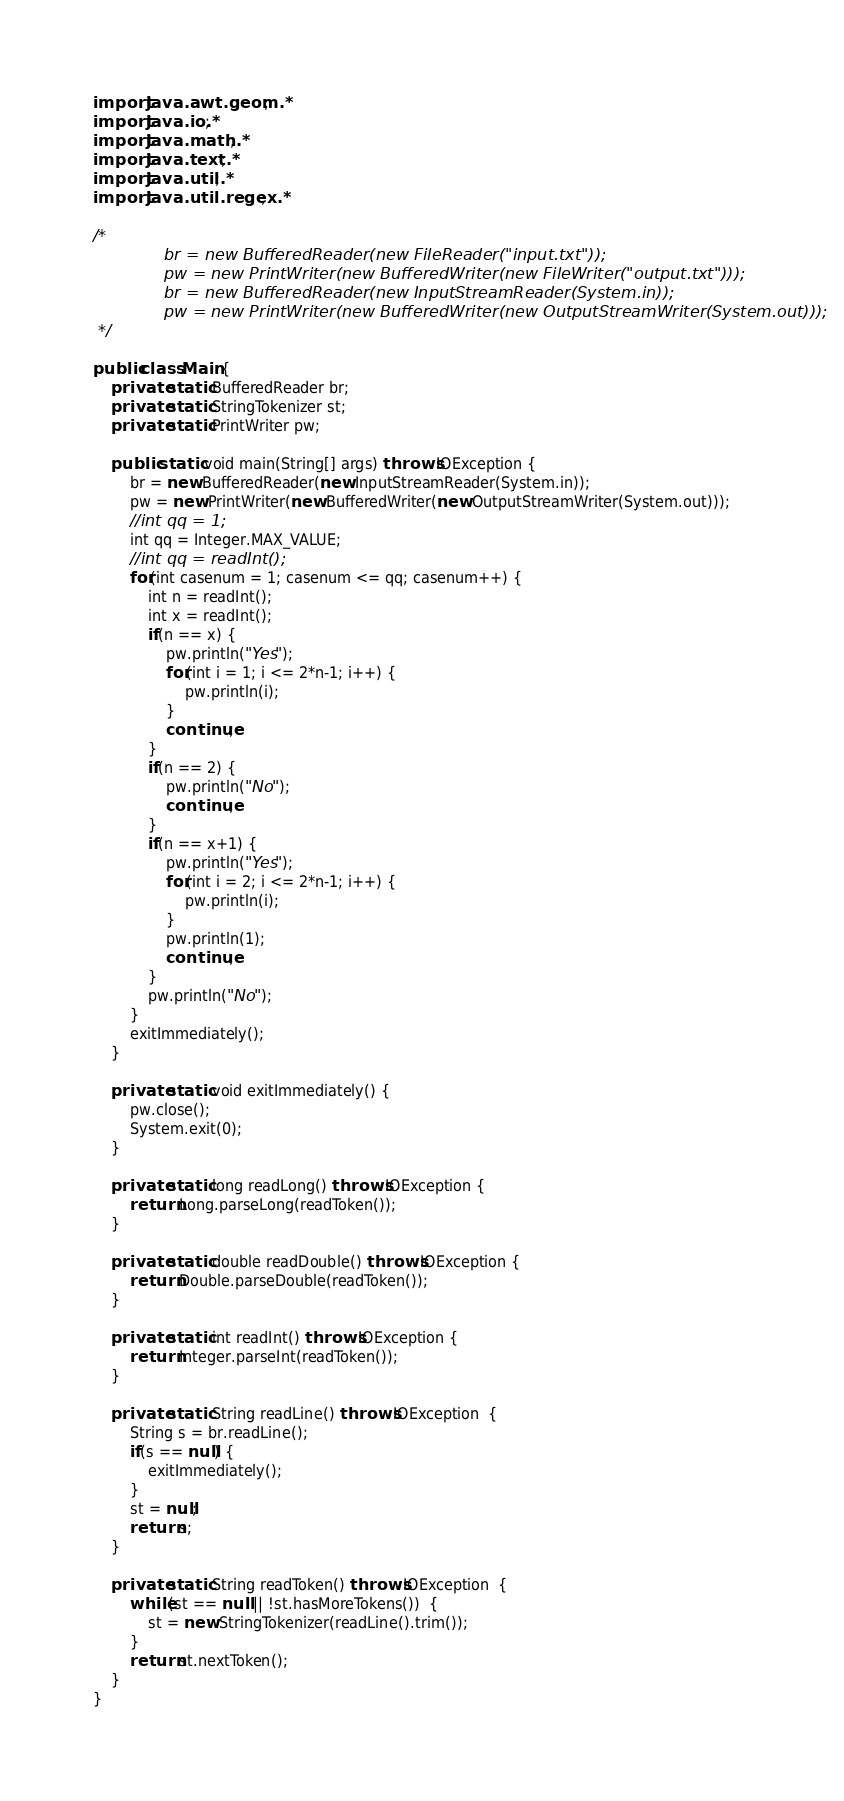Convert code to text. <code><loc_0><loc_0><loc_500><loc_500><_Java_>import java.awt.geom.*;
import java.io.*;
import java.math.*;
import java.text.*; 
import java.util.*;
import java.util.regex.*;

/*
			  br = new BufferedReader(new FileReader("input.txt"));
			  pw = new PrintWriter(new BufferedWriter(new FileWriter("output.txt")));
			  br = new BufferedReader(new InputStreamReader(System.in));
			  pw = new PrintWriter(new BufferedWriter(new OutputStreamWriter(System.out)));
 */

public class Main {
	private static BufferedReader br;
	private static StringTokenizer st;
	private static PrintWriter pw;

	public static void main(String[] args) throws IOException {
		br = new BufferedReader(new InputStreamReader(System.in));
		pw = new PrintWriter(new BufferedWriter(new OutputStreamWriter(System.out)));
		//int qq = 1;
		int qq = Integer.MAX_VALUE;
		//int qq = readInt();
		for(int casenum = 1; casenum <= qq; casenum++) {
			int n = readInt();
			int x = readInt();
			if(n == x) {
				pw.println("Yes");
				for(int i = 1; i <= 2*n-1; i++) {
					pw.println(i);
				}
				continue;
			}
			if(n == 2) {
				pw.println("No");
				continue;
			}
			if(n == x+1) {
				pw.println("Yes");
				for(int i = 2; i <= 2*n-1; i++) {
					pw.println(i);
				}
				pw.println(1);
				continue;
			}
			pw.println("No");
		}
		exitImmediately();
	}

	private static void exitImmediately() {
		pw.close();
		System.exit(0);
	}

	private static long readLong() throws IOException {
		return Long.parseLong(readToken());
	}

	private static double readDouble() throws IOException {
		return Double.parseDouble(readToken());
	}

	private static int readInt() throws IOException {
		return Integer.parseInt(readToken());
	}

	private static String readLine() throws IOException  {
		String s = br.readLine();
		if(s == null) {
			exitImmediately();
		}
		st = null;
		return s;
	}

	private static String readToken() throws IOException  {
		while(st == null || !st.hasMoreTokens())  {
			st = new StringTokenizer(readLine().trim());
		}
		return st.nextToken();
	}
}</code> 